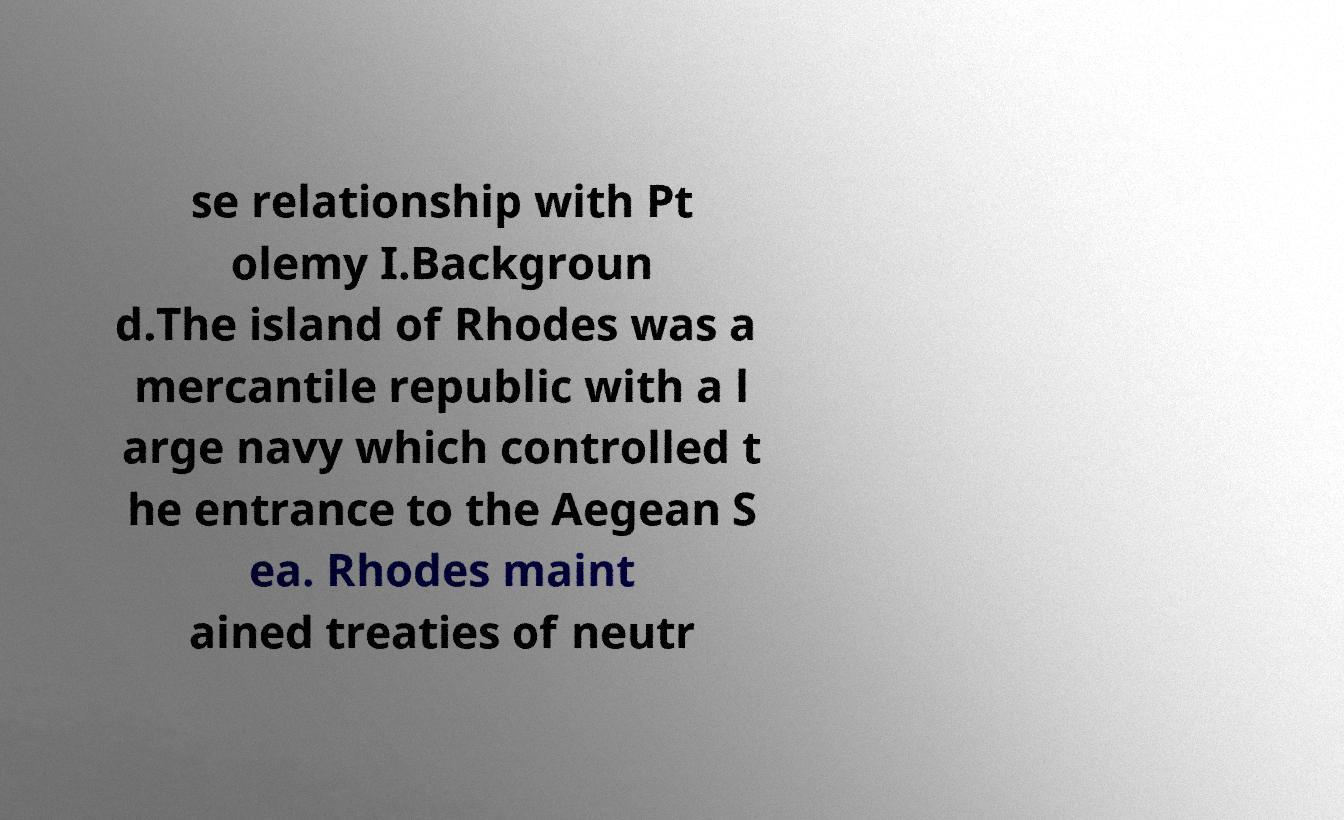Please identify and transcribe the text found in this image. se relationship with Pt olemy I.Backgroun d.The island of Rhodes was a mercantile republic with a l arge navy which controlled t he entrance to the Aegean S ea. Rhodes maint ained treaties of neutr 